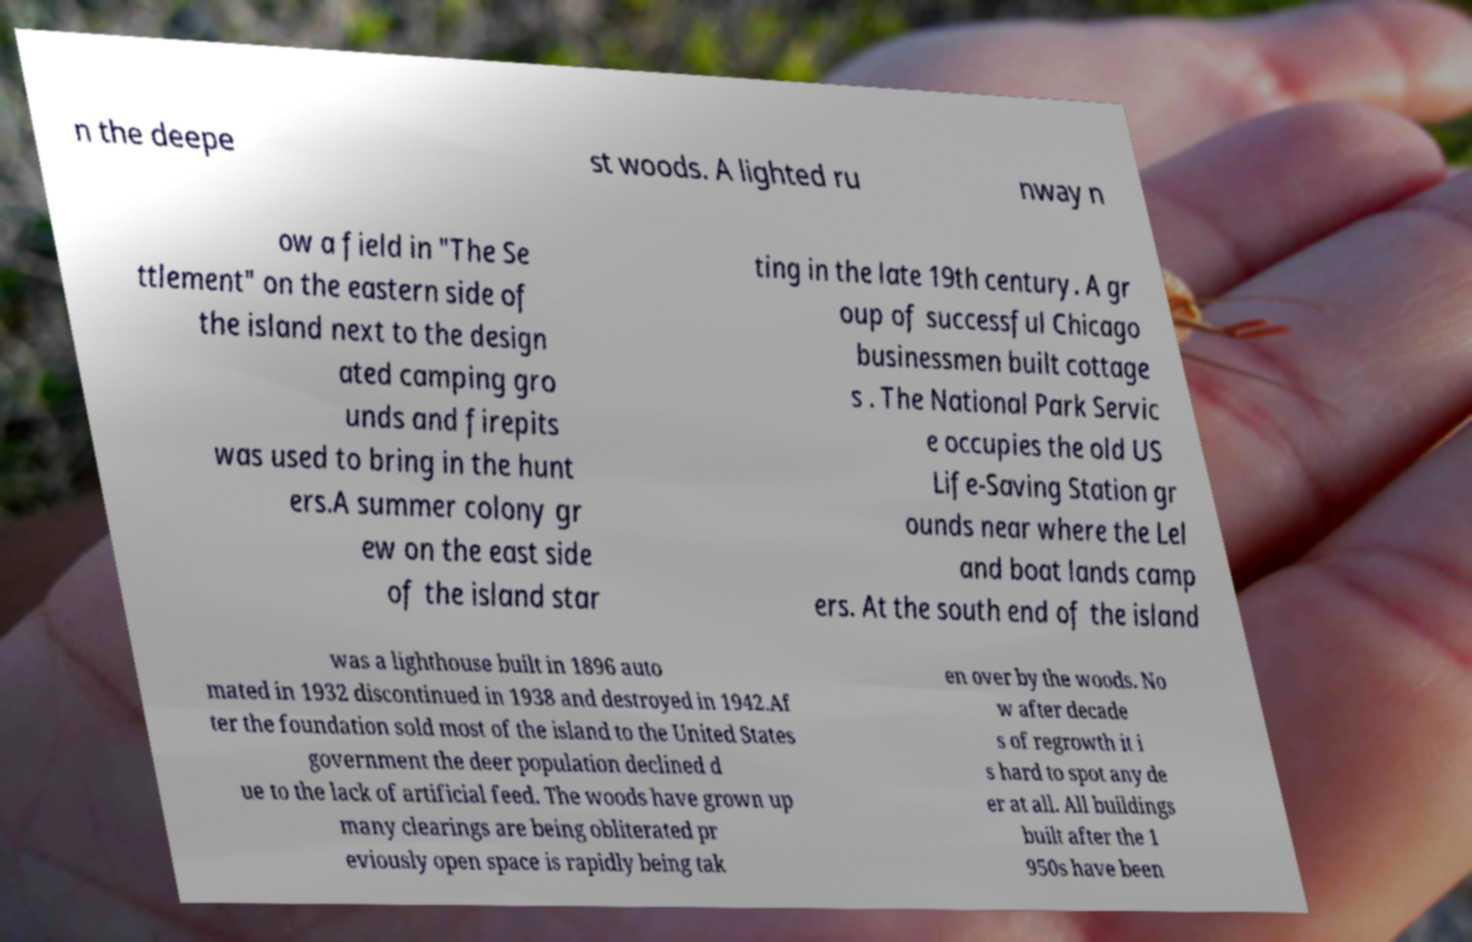Could you extract and type out the text from this image? n the deepe st woods. A lighted ru nway n ow a field in "The Se ttlement" on the eastern side of the island next to the design ated camping gro unds and firepits was used to bring in the hunt ers.A summer colony gr ew on the east side of the island star ting in the late 19th century. A gr oup of successful Chicago businessmen built cottage s . The National Park Servic e occupies the old US Life-Saving Station gr ounds near where the Lel and boat lands camp ers. At the south end of the island was a lighthouse built in 1896 auto mated in 1932 discontinued in 1938 and destroyed in 1942.Af ter the foundation sold most of the island to the United States government the deer population declined d ue to the lack of artificial feed. The woods have grown up many clearings are being obliterated pr eviously open space is rapidly being tak en over by the woods. No w after decade s of regrowth it i s hard to spot any de er at all. All buildings built after the 1 950s have been 